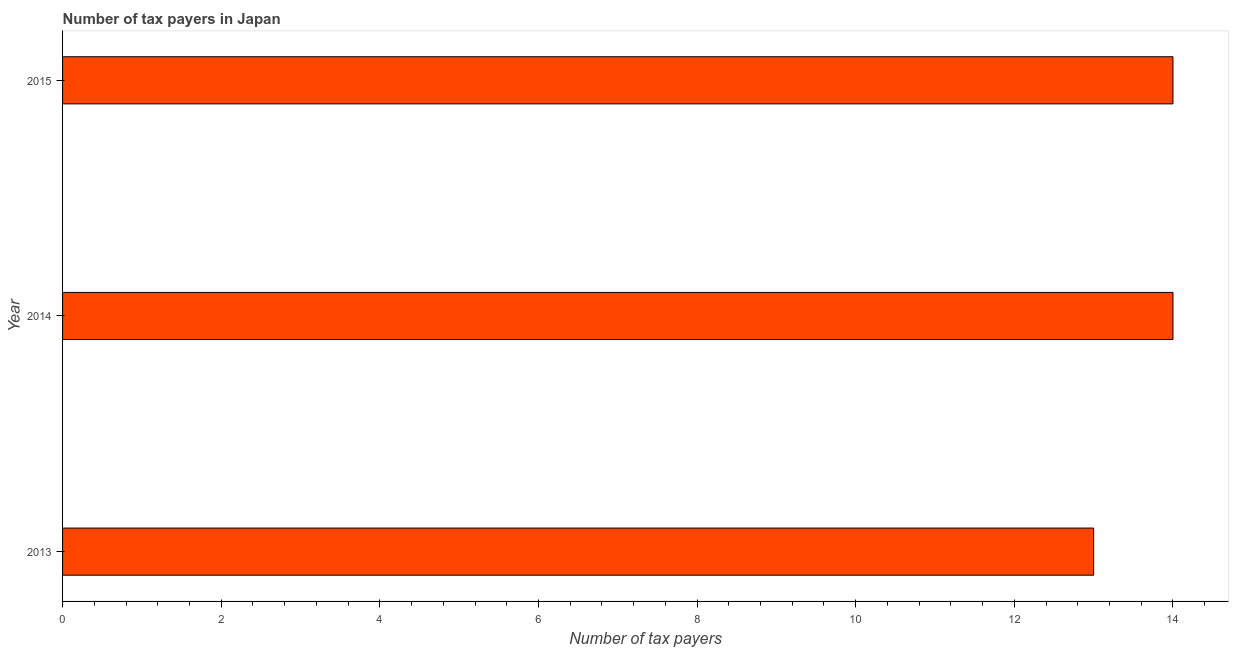Does the graph contain any zero values?
Provide a short and direct response. No. Does the graph contain grids?
Ensure brevity in your answer.  No. What is the title of the graph?
Keep it short and to the point. Number of tax payers in Japan. What is the label or title of the X-axis?
Provide a short and direct response. Number of tax payers. What is the label or title of the Y-axis?
Give a very brief answer. Year. What is the number of tax payers in 2015?
Provide a succinct answer. 14. Across all years, what is the minimum number of tax payers?
Keep it short and to the point. 13. In which year was the number of tax payers maximum?
Offer a very short reply. 2014. In which year was the number of tax payers minimum?
Your answer should be compact. 2013. What is the average number of tax payers per year?
Ensure brevity in your answer.  13. In how many years, is the number of tax payers greater than 2.8 ?
Your answer should be very brief. 3. What is the ratio of the number of tax payers in 2013 to that in 2014?
Your answer should be compact. 0.93. Is the sum of the number of tax payers in 2013 and 2014 greater than the maximum number of tax payers across all years?
Offer a terse response. Yes. What is the difference between the highest and the lowest number of tax payers?
Offer a terse response. 1. How many bars are there?
Your answer should be compact. 3. Are all the bars in the graph horizontal?
Offer a very short reply. Yes. How many years are there in the graph?
Your response must be concise. 3. What is the difference between two consecutive major ticks on the X-axis?
Give a very brief answer. 2. What is the difference between the Number of tax payers in 2013 and 2014?
Keep it short and to the point. -1. What is the difference between the Number of tax payers in 2013 and 2015?
Keep it short and to the point. -1. What is the difference between the Number of tax payers in 2014 and 2015?
Make the answer very short. 0. What is the ratio of the Number of tax payers in 2013 to that in 2014?
Provide a succinct answer. 0.93. What is the ratio of the Number of tax payers in 2013 to that in 2015?
Provide a succinct answer. 0.93. 